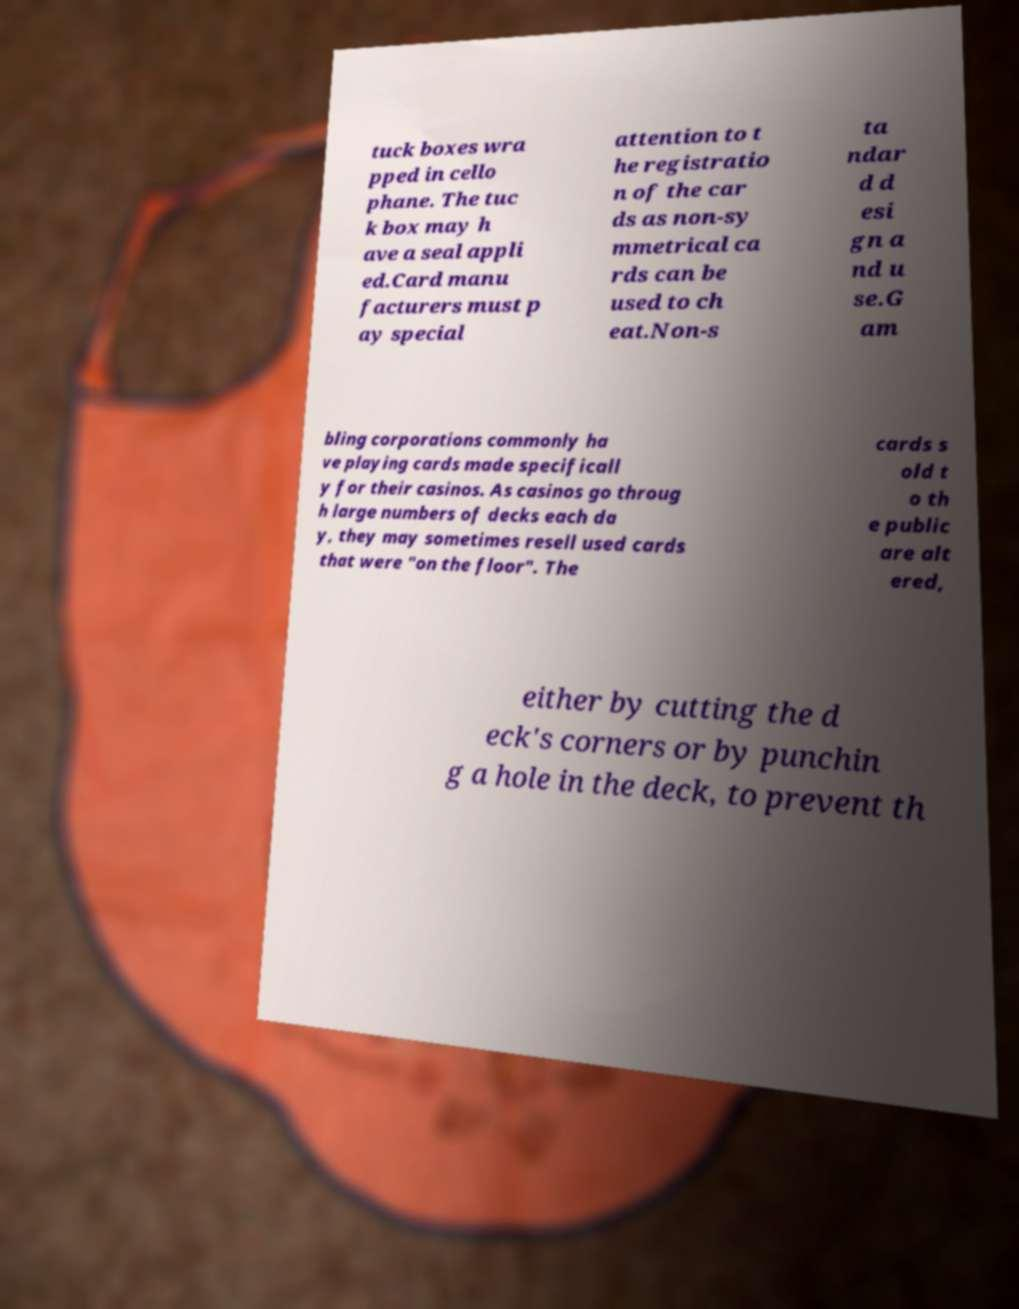What messages or text are displayed in this image? I need them in a readable, typed format. tuck boxes wra pped in cello phane. The tuc k box may h ave a seal appli ed.Card manu facturers must p ay special attention to t he registratio n of the car ds as non-sy mmetrical ca rds can be used to ch eat.Non-s ta ndar d d esi gn a nd u se.G am bling corporations commonly ha ve playing cards made specificall y for their casinos. As casinos go throug h large numbers of decks each da y, they may sometimes resell used cards that were "on the floor". The cards s old t o th e public are alt ered, either by cutting the d eck's corners or by punchin g a hole in the deck, to prevent th 